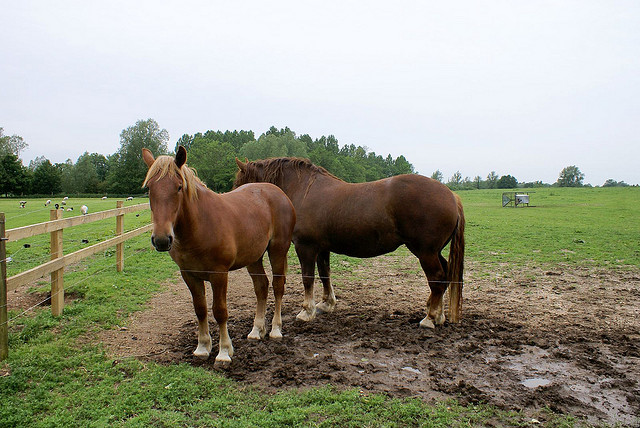<image>What number of grass blades are in the field? It is impossible to tell the exact number of grass blades in the field. What number of grass blades are in the field? I don't know the exact number of grass blades in the field. But it can be seen that there are many. 